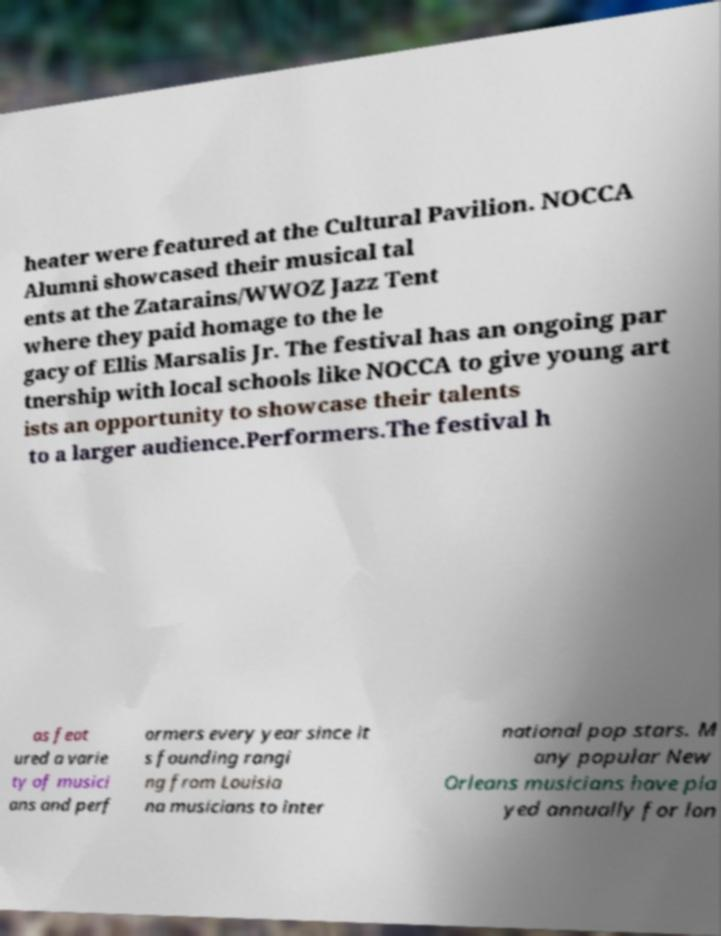What messages or text are displayed in this image? I need them in a readable, typed format. heater were featured at the Cultural Pavilion. NOCCA Alumni showcased their musical tal ents at the Zatarains/WWOZ Jazz Tent where they paid homage to the le gacy of Ellis Marsalis Jr. The festival has an ongoing par tnership with local schools like NOCCA to give young art ists an opportunity to showcase their talents to a larger audience.Performers.The festival h as feat ured a varie ty of musici ans and perf ormers every year since it s founding rangi ng from Louisia na musicians to inter national pop stars. M any popular New Orleans musicians have pla yed annually for lon 